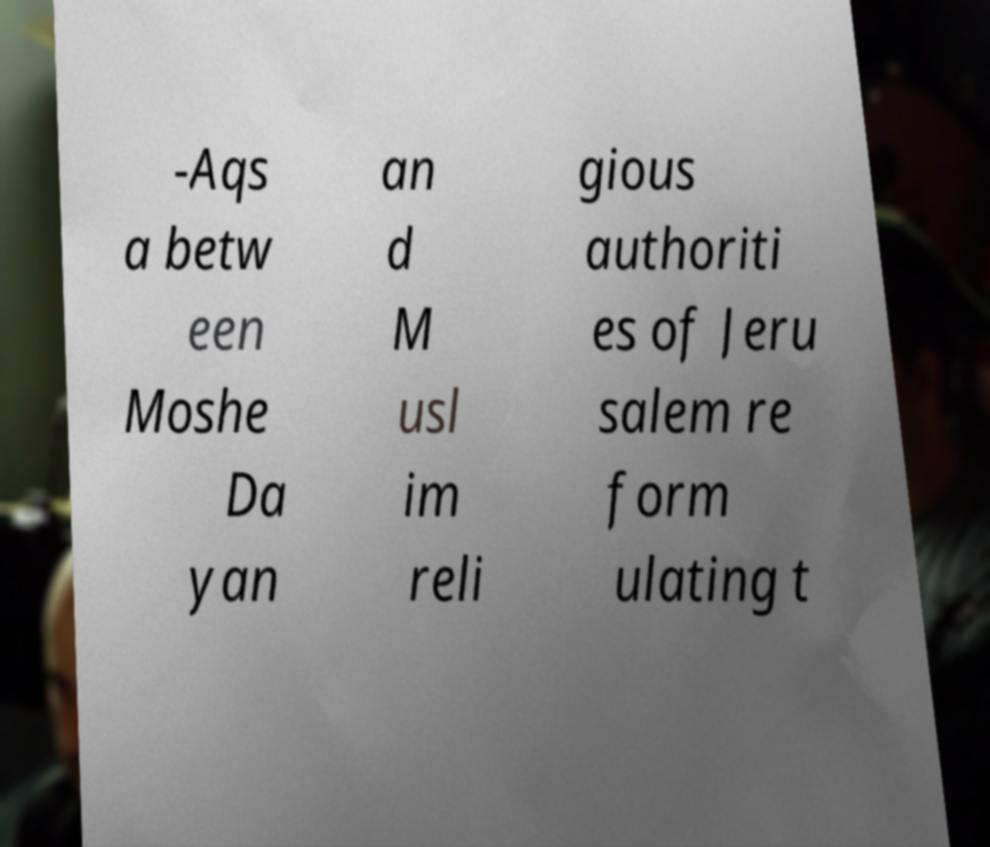For documentation purposes, I need the text within this image transcribed. Could you provide that? -Aqs a betw een Moshe Da yan an d M usl im reli gious authoriti es of Jeru salem re form ulating t 